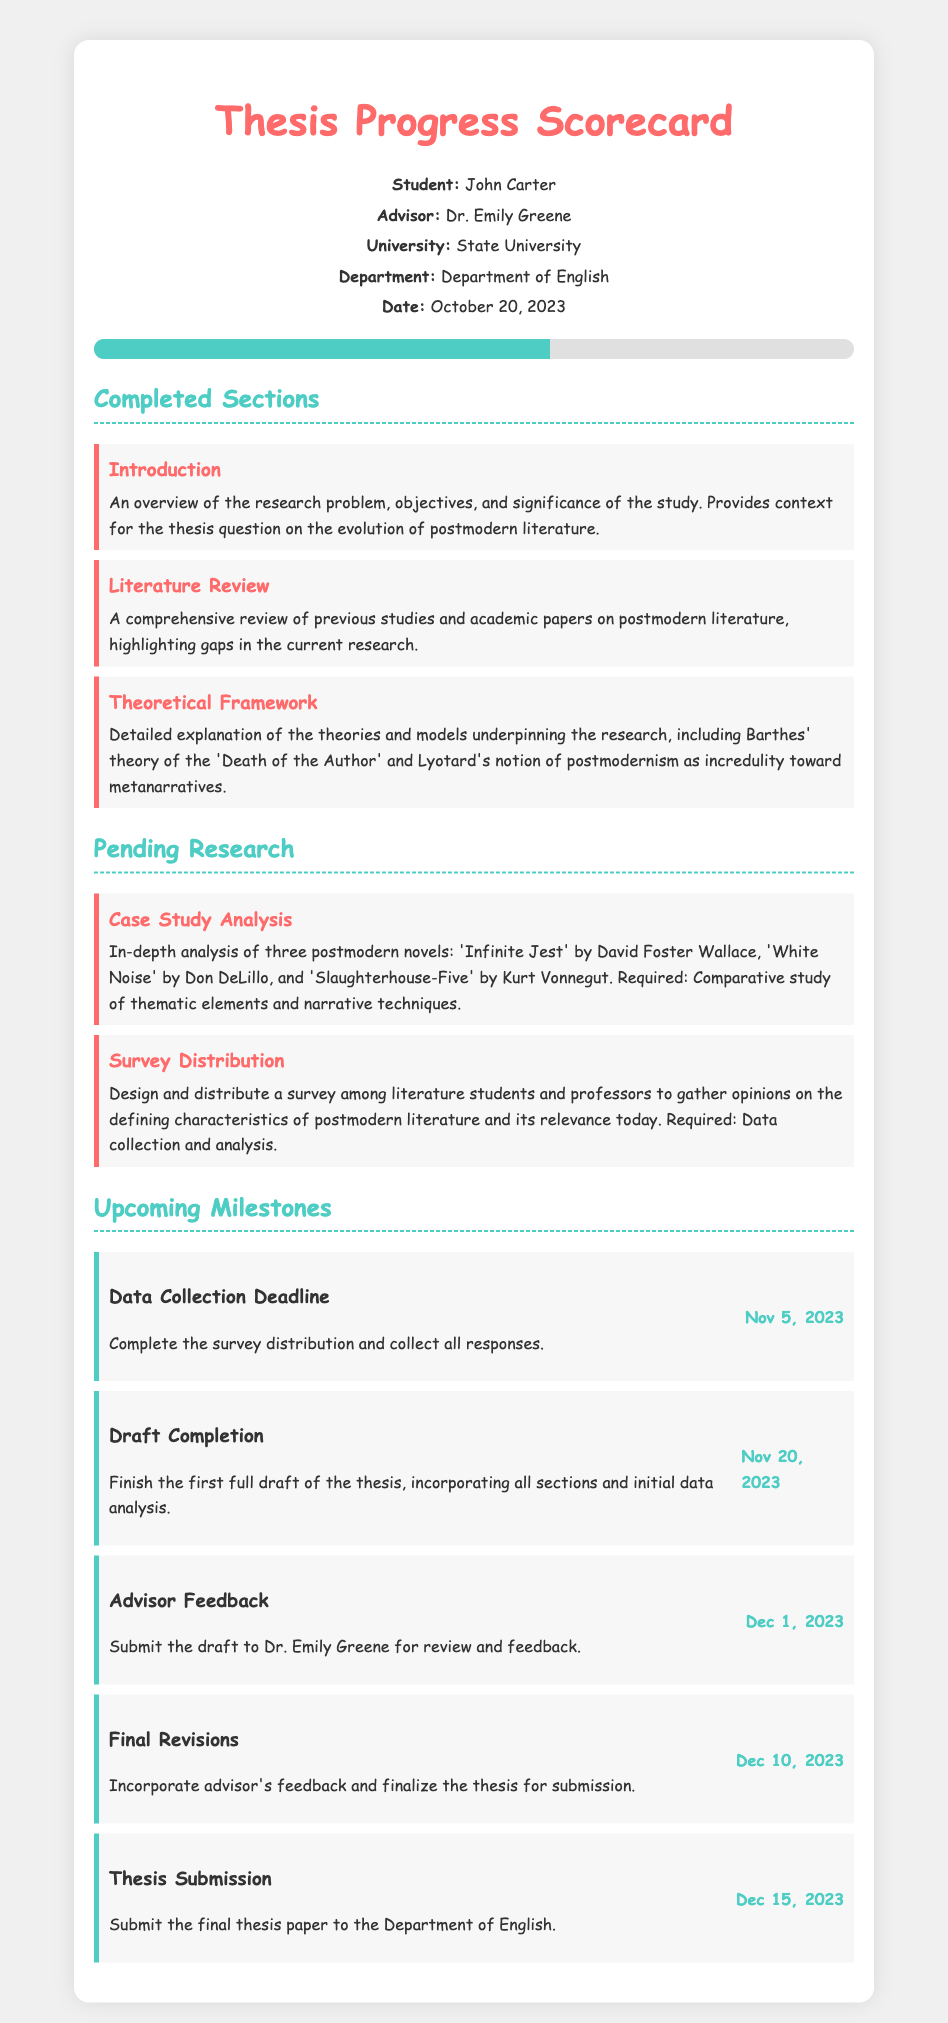What is the student's name? The student's name is presented at the beginning of the scorecard.
Answer: John Carter What is the date of the progress report? The date is noted in the student info section of the document.
Answer: October 20, 2023 What section has been completed that focuses on previous research? This information comes from the completed sections of the document.
Answer: Literature Review How many novels are included in the case study analysis? The information can be found in the pending research section.
Answer: Three What is the deadline for data collection? The upcoming milestones section lists this specific deadline.
Answer: Nov 5, 2023 Which theoretical framework is mentioned in the completed sections? This requires referring to the theoretical framework section of the document.
Answer: Barthes' theory of the 'Death of the Author' When is the thesis submission date? This date is listed in the upcoming milestones section of the scorecard.
Answer: Dec 15, 2023 What is one of the upcoming milestones regarding advisor feedback? This information can be deduced from the section on upcoming milestones.
Answer: Dec 1, 2023 What are the thematic elements analyzed in the case study? This comes from the pending research section, requiring inference based on the specific novels mentioned.
Answer: Comparative study of thematic elements and narrative techniques 